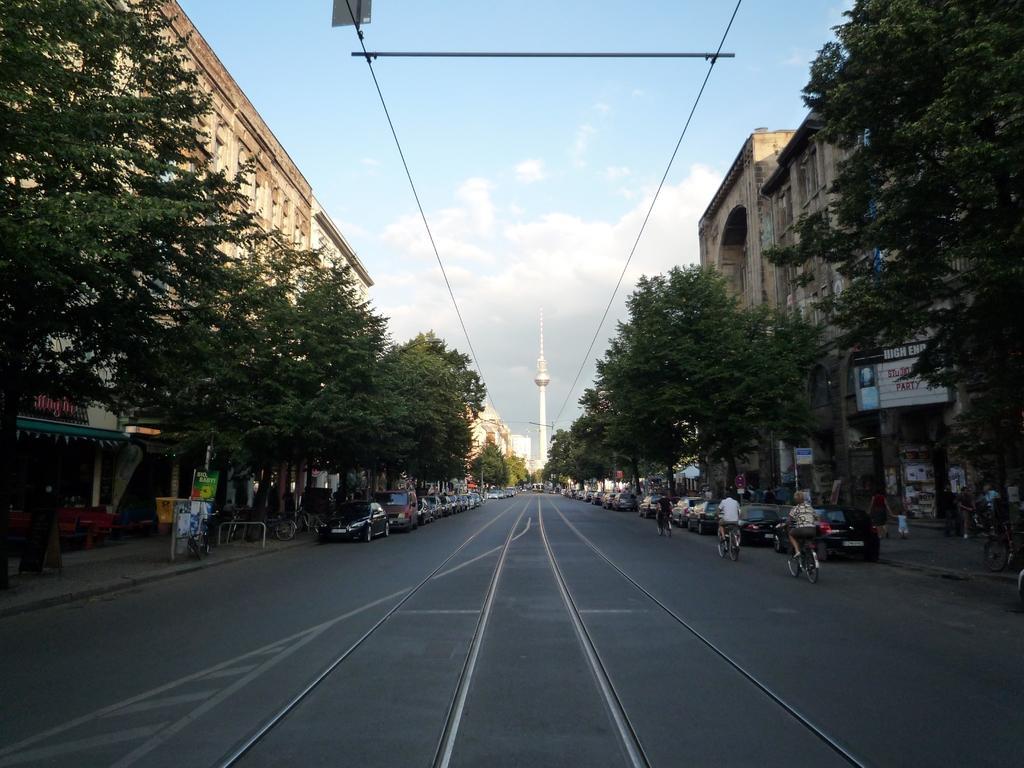Could you give a brief overview of what you see in this image? In this picture we can see three persons are riding bicycles, on the right side and left side there are buildings, trees and cars, we can see a tower in the background, on the right side there are boards, we can see the sky at the top of the picture. 